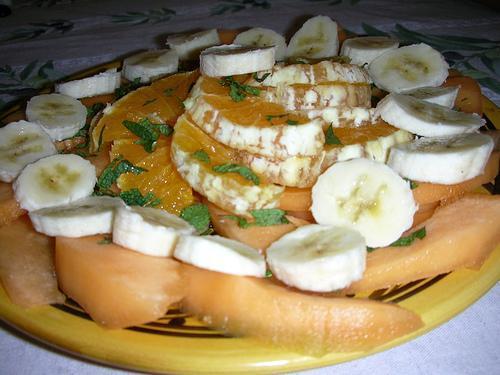How many types of fruit do you see?
Give a very brief answer. 3. How many bananas are there?
Give a very brief answer. 10. How many oranges are there?
Give a very brief answer. 8. 